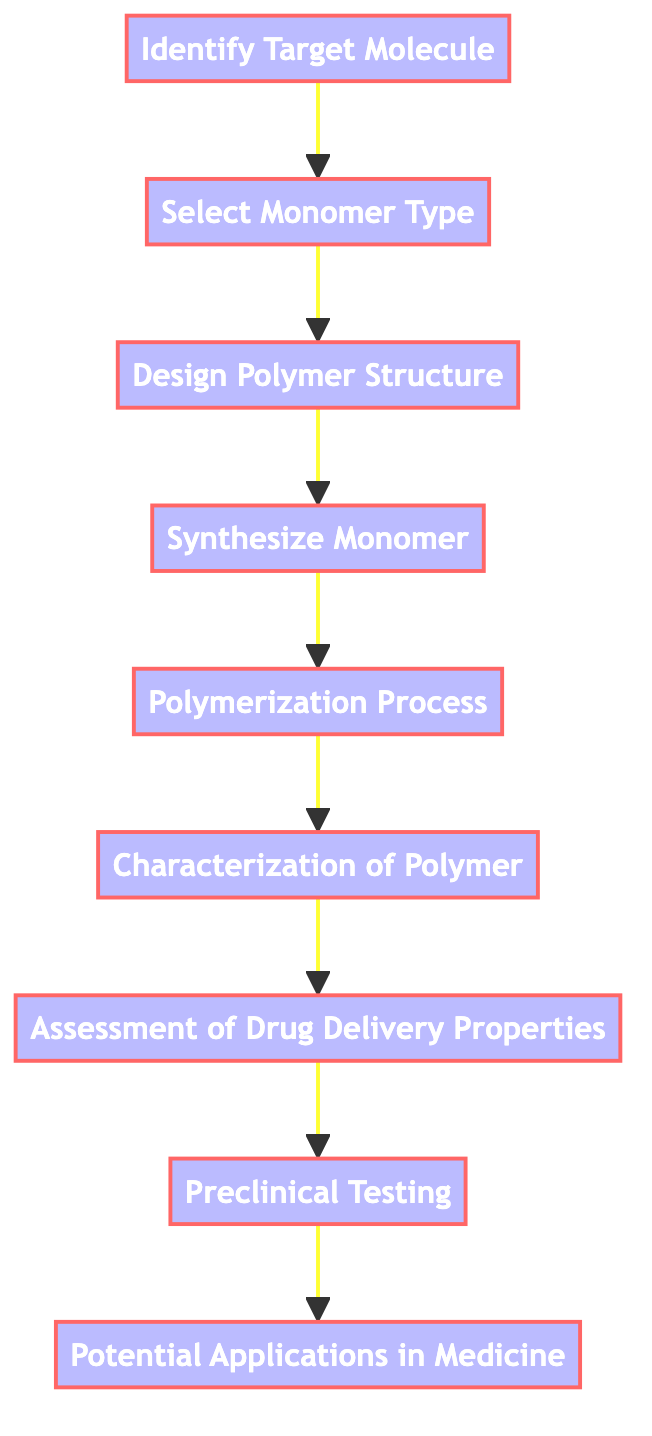What is the first step in the synthesis process? The first step in the process is "Identify Target Molecule," which is the starting point as indicated in the diagram.
Answer: Identify Target Molecule How many nodes are present in the diagram? The diagram includes a total of 9 nodes which represent different stages in the polymer synthesis process.
Answer: 9 What is the last step before identifying potential applications in medicine? The last step before reaching the node for "Potential Applications in Medicine" is "Preclinical Testing," as shown as a direct predecessor in the flow.
Answer: Preclinical Testing Which step involves evaluating drug delivery properties? The step that involves evaluating drug delivery properties is "Assessment of Drug Delivery Properties," which directly follows the "Characterization of Polymer" step.
Answer: Assessment of Drug Delivery Properties What are the two nodes connected directly by an edge after "Design Polymer Structure"? The two nodes connected directly by an edge after "Design Polymer Structure" are "Synthesize Monomer" and "Select Monomer Type," as both are part of succeeding steps in the synthesis process.
Answer: Synthesize Monomer and Select Monomer Type What is the relationship between "Synthesize Monomer" and "Characterization of Polymer"? "Synthesize Monomer" leads directly to "Polymerization Process," which then leads to "Characterization of Polymer," indicating a sequential steps relationship in the flow of the processes.
Answer: Sequential steps relationship Which node follows the process of polymerization? The node that follows the process of polymerization, as indicated by the directed flow, is "Characterization of Polymer."
Answer: Characterization of Polymer Name the last node in the directed graph. The last node in the directed graph is "Potential Applications in Medicine," which concludes the chain of the synthetic process flow.
Answer: Potential Applications in Medicine Which step is characterized by assessing the polymer’s capability in drug delivery? The step characterized by assessing the polymer's capability in drug delivery is "Assessment of Drug Delivery Properties," which focuses specifically on this evaluation.
Answer: Assessment of Drug Delivery Properties 